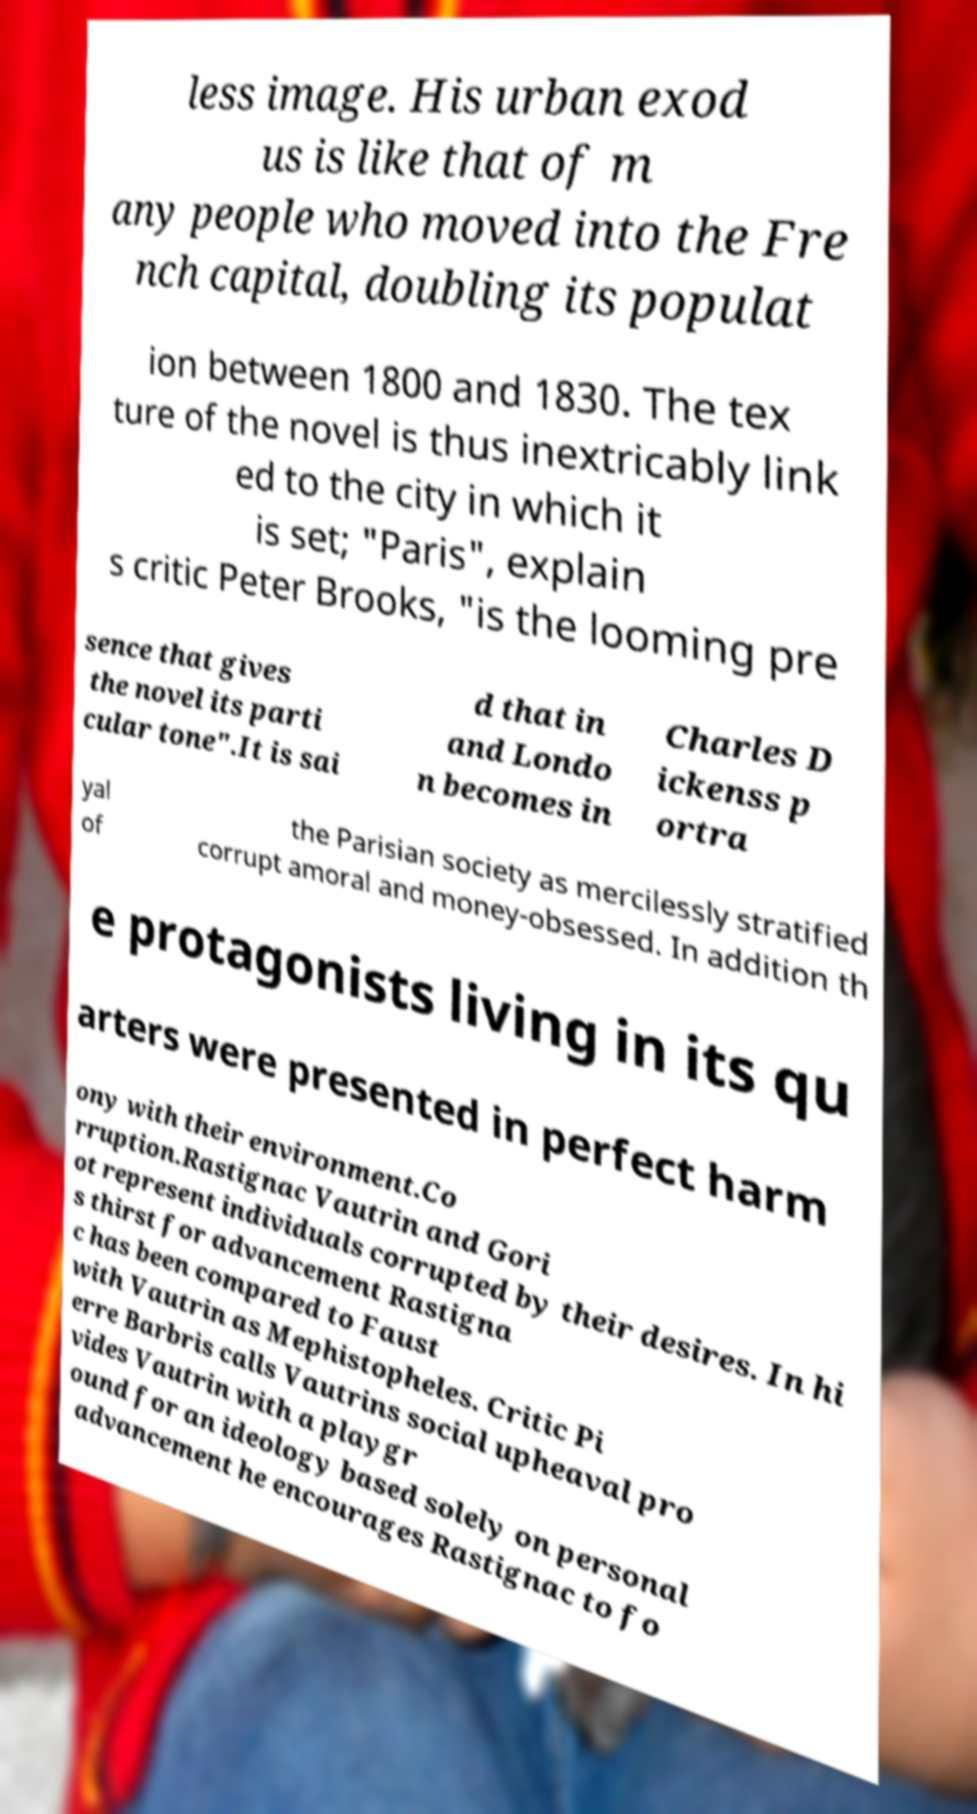Can you read and provide the text displayed in the image?This photo seems to have some interesting text. Can you extract and type it out for me? less image. His urban exod us is like that of m any people who moved into the Fre nch capital, doubling its populat ion between 1800 and 1830. The tex ture of the novel is thus inextricably link ed to the city in which it is set; "Paris", explain s critic Peter Brooks, "is the looming pre sence that gives the novel its parti cular tone".It is sai d that in and Londo n becomes in Charles D ickenss p ortra yal of the Parisian society as mercilessly stratified corrupt amoral and money-obsessed. In addition th e protagonists living in its qu arters were presented in perfect harm ony with their environment.Co rruption.Rastignac Vautrin and Gori ot represent individuals corrupted by their desires. In hi s thirst for advancement Rastigna c has been compared to Faust with Vautrin as Mephistopheles. Critic Pi erre Barbris calls Vautrins social upheaval pro vides Vautrin with a playgr ound for an ideology based solely on personal advancement he encourages Rastignac to fo 